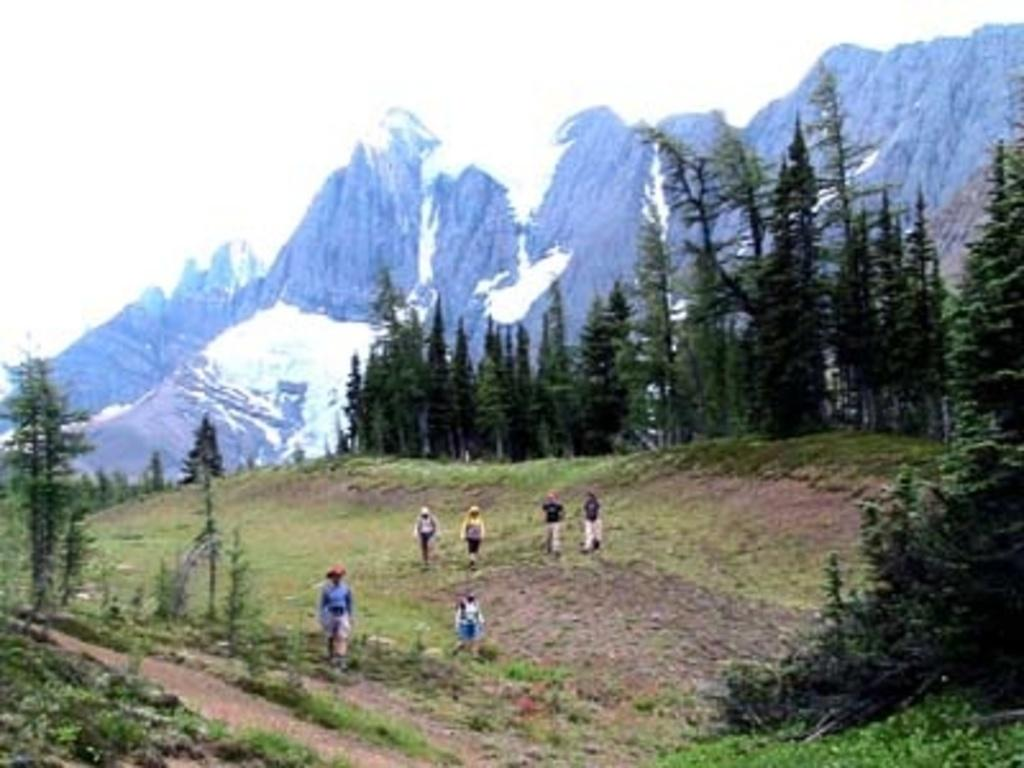What type of vegetation can be seen in the image? There are trees and grass visible in the image. What is the ground like in the image? The ground is visible in the image. What are the persons in the image standing on? The persons in the image are standing on the ground. What can be seen in the background of the image? There are mountains and the sky visible in the background of the image. What is the condition of the mountains in the image? The mountains have snow on them. Can you tell me how many arches are present in the image? There are no arches present in the image. What type of musical instrument is being played by the person in the image? There are no persons playing a guitar or any musical instrument in the image. 